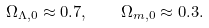Convert formula to latex. <formula><loc_0><loc_0><loc_500><loc_500>\Omega _ { \Lambda , 0 } \approx 0 . 7 , \quad \Omega _ { m , 0 } \approx 0 . 3 .</formula> 